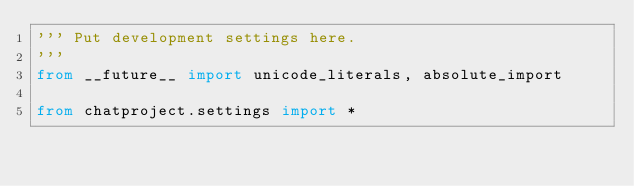Convert code to text. <code><loc_0><loc_0><loc_500><loc_500><_Python_>''' Put development settings here.
'''
from __future__ import unicode_literals, absolute_import

from chatproject.settings import *
</code> 